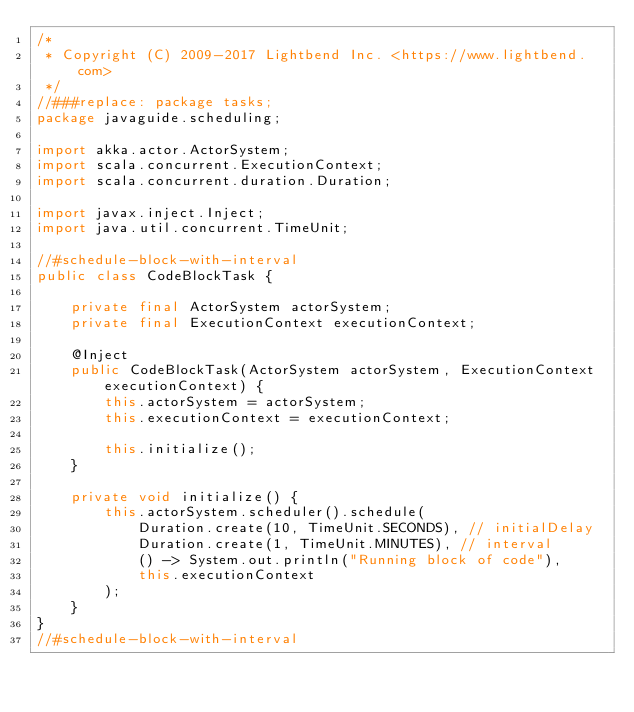<code> <loc_0><loc_0><loc_500><loc_500><_Java_>/*
 * Copyright (C) 2009-2017 Lightbend Inc. <https://www.lightbend.com>
 */
//###replace: package tasks;
package javaguide.scheduling;

import akka.actor.ActorSystem;
import scala.concurrent.ExecutionContext;
import scala.concurrent.duration.Duration;

import javax.inject.Inject;
import java.util.concurrent.TimeUnit;

//#schedule-block-with-interval
public class CodeBlockTask {

    private final ActorSystem actorSystem;
    private final ExecutionContext executionContext;

    @Inject
    public CodeBlockTask(ActorSystem actorSystem, ExecutionContext executionContext) {
        this.actorSystem = actorSystem;
        this.executionContext = executionContext;

        this.initialize();
    }

    private void initialize() {
        this.actorSystem.scheduler().schedule(
            Duration.create(10, TimeUnit.SECONDS), // initialDelay
            Duration.create(1, TimeUnit.MINUTES), // interval
            () -> System.out.println("Running block of code"),
            this.executionContext
        );
    }
}
//#schedule-block-with-interval
</code> 